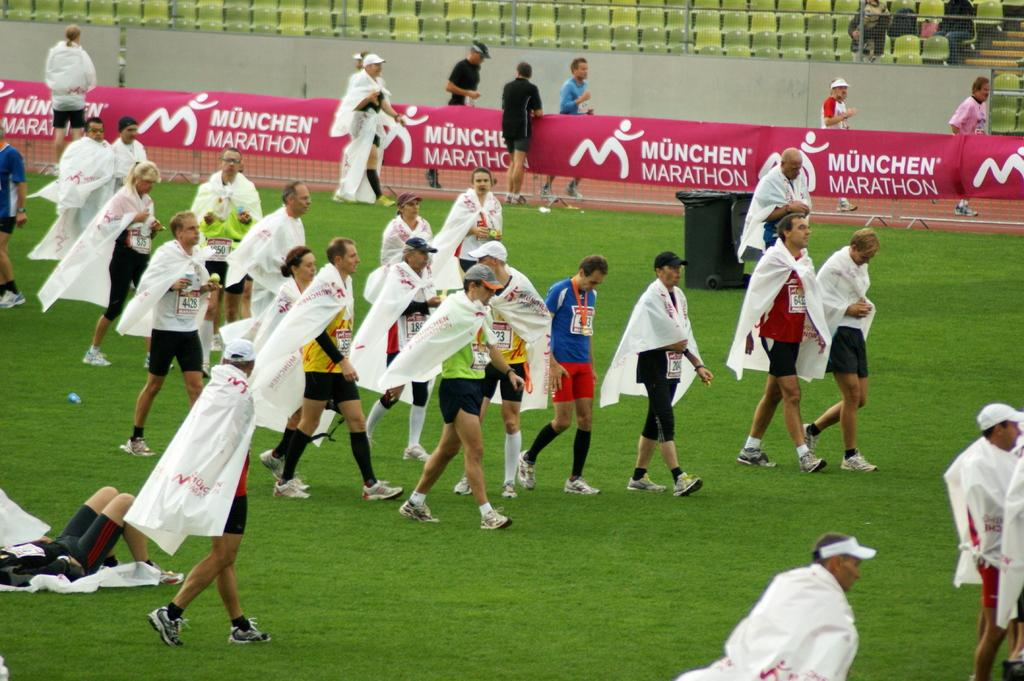Provide a one-sentence caption for the provided image. A group of people wearing shorts and white capes ona grassy field for the Munchen Marathon. 